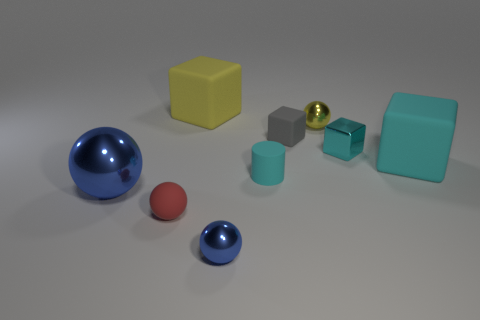Is the shape of the blue metal thing to the left of the small blue ball the same as  the red matte object?
Provide a succinct answer. Yes. What number of objects are either tiny objects on the left side of the small cyan block or tiny metal balls in front of the red matte thing?
Provide a succinct answer. 5. What color is the other tiny matte thing that is the same shape as the small blue object?
Offer a terse response. Red. Are there any other things that have the same shape as the small cyan rubber object?
Your answer should be compact. No. Do the small cyan metal object and the rubber thing behind the yellow sphere have the same shape?
Keep it short and to the point. Yes. What is the material of the small cyan cylinder?
Make the answer very short. Rubber. There is a yellow matte object that is the same shape as the large cyan object; what is its size?
Offer a very short reply. Large. What number of other things are there of the same material as the tiny cylinder
Keep it short and to the point. 4. Do the yellow sphere and the large sphere that is left of the cyan shiny cube have the same material?
Your response must be concise. Yes. Is the number of small yellow shiny things that are to the left of the tiny yellow metal thing less than the number of big matte blocks that are on the right side of the tiny red thing?
Your response must be concise. Yes. 